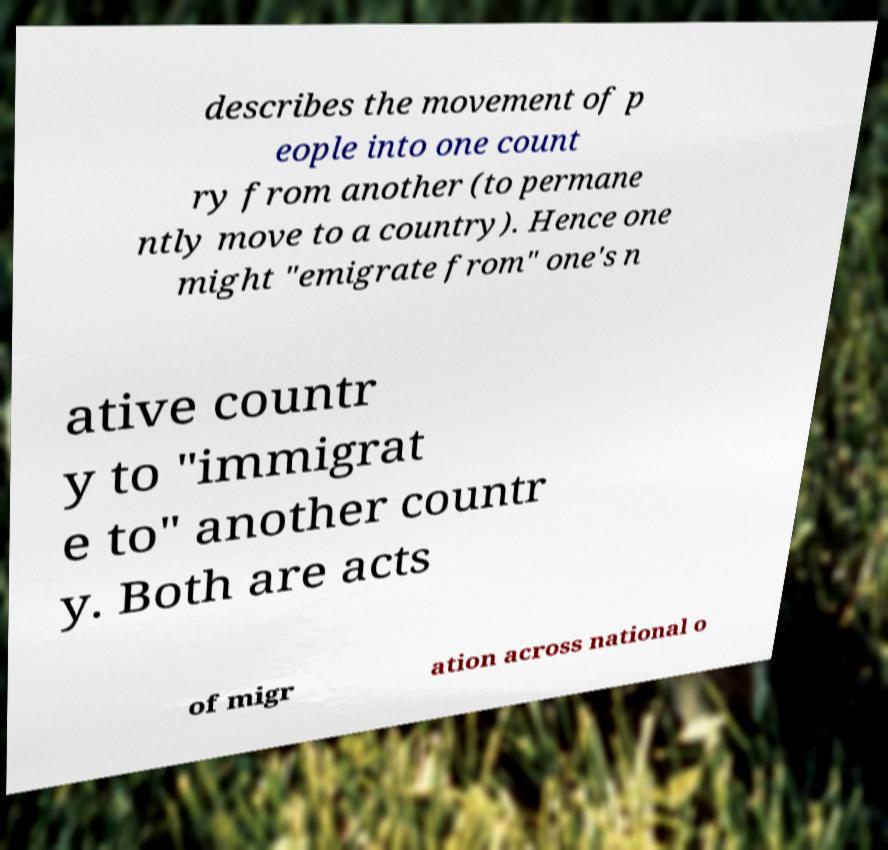Could you extract and type out the text from this image? describes the movement of p eople into one count ry from another (to permane ntly move to a country). Hence one might "emigrate from" one's n ative countr y to "immigrat e to" another countr y. Both are acts of migr ation across national o 